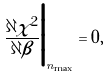<formula> <loc_0><loc_0><loc_500><loc_500>\frac { \partial \chi ^ { 2 } } { \partial \beta } \Big | _ { n _ { \max } } = 0 ,</formula> 